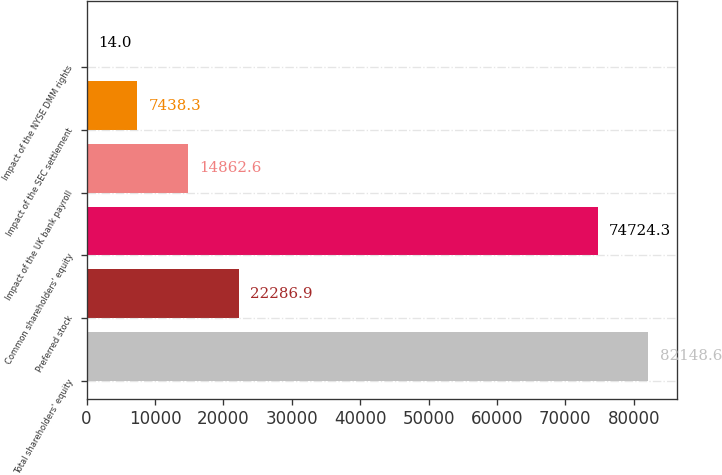Convert chart to OTSL. <chart><loc_0><loc_0><loc_500><loc_500><bar_chart><fcel>Total shareholders' equity<fcel>Preferred stock<fcel>Common shareholders' equity<fcel>Impact of the UK bank payroll<fcel>Impact of the SEC settlement<fcel>Impact of the NYSE DMM rights<nl><fcel>82148.6<fcel>22286.9<fcel>74724.3<fcel>14862.6<fcel>7438.3<fcel>14<nl></chart> 